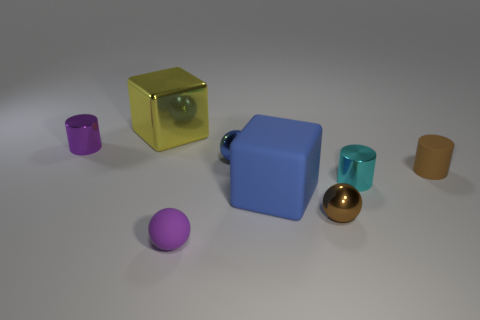Subtract all small rubber cylinders. How many cylinders are left? 2 Add 2 big yellow cylinders. How many objects exist? 10 Subtract all gray balls. How many blue blocks are left? 1 Subtract all big red things. Subtract all small blue balls. How many objects are left? 7 Add 4 large blue matte blocks. How many large blue matte blocks are left? 5 Add 2 large rubber blocks. How many large rubber blocks exist? 3 Subtract all yellow cubes. How many cubes are left? 1 Subtract 0 yellow cylinders. How many objects are left? 8 Subtract all spheres. How many objects are left? 5 Subtract 3 spheres. How many spheres are left? 0 